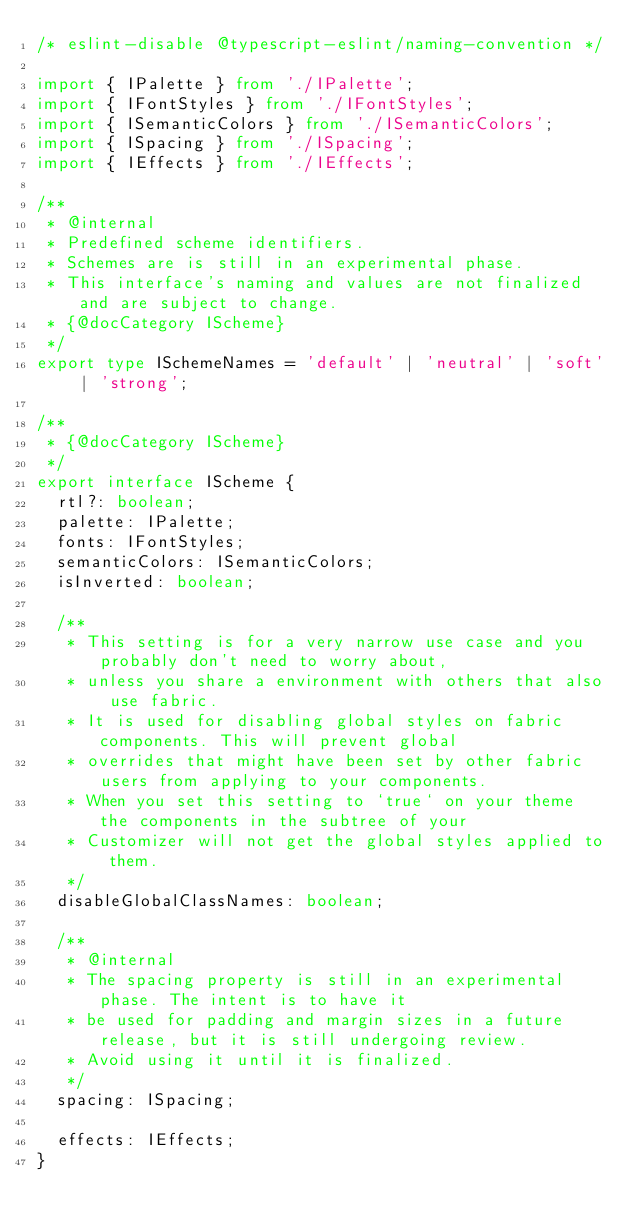<code> <loc_0><loc_0><loc_500><loc_500><_TypeScript_>/* eslint-disable @typescript-eslint/naming-convention */

import { IPalette } from './IPalette';
import { IFontStyles } from './IFontStyles';
import { ISemanticColors } from './ISemanticColors';
import { ISpacing } from './ISpacing';
import { IEffects } from './IEffects';

/**
 * @internal
 * Predefined scheme identifiers.
 * Schemes are is still in an experimental phase.
 * This interface's naming and values are not finalized and are subject to change.
 * {@docCategory IScheme}
 */
export type ISchemeNames = 'default' | 'neutral' | 'soft' | 'strong';

/**
 * {@docCategory IScheme}
 */
export interface IScheme {
  rtl?: boolean;
  palette: IPalette;
  fonts: IFontStyles;
  semanticColors: ISemanticColors;
  isInverted: boolean;

  /**
   * This setting is for a very narrow use case and you probably don't need to worry about,
   * unless you share a environment with others that also use fabric.
   * It is used for disabling global styles on fabric components. This will prevent global
   * overrides that might have been set by other fabric users from applying to your components.
   * When you set this setting to `true` on your theme the components in the subtree of your
   * Customizer will not get the global styles applied to them.
   */
  disableGlobalClassNames: boolean;

  /**
   * @internal
   * The spacing property is still in an experimental phase. The intent is to have it
   * be used for padding and margin sizes in a future release, but it is still undergoing review.
   * Avoid using it until it is finalized.
   */
  spacing: ISpacing;

  effects: IEffects;
}
</code> 